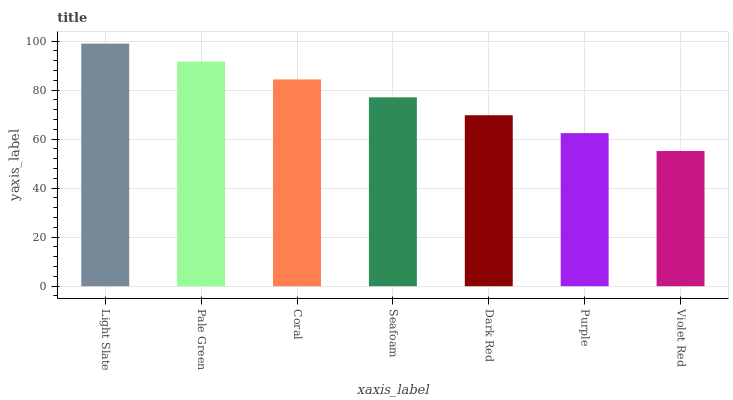Is Violet Red the minimum?
Answer yes or no. Yes. Is Light Slate the maximum?
Answer yes or no. Yes. Is Pale Green the minimum?
Answer yes or no. No. Is Pale Green the maximum?
Answer yes or no. No. Is Light Slate greater than Pale Green?
Answer yes or no. Yes. Is Pale Green less than Light Slate?
Answer yes or no. Yes. Is Pale Green greater than Light Slate?
Answer yes or no. No. Is Light Slate less than Pale Green?
Answer yes or no. No. Is Seafoam the high median?
Answer yes or no. Yes. Is Seafoam the low median?
Answer yes or no. Yes. Is Pale Green the high median?
Answer yes or no. No. Is Light Slate the low median?
Answer yes or no. No. 